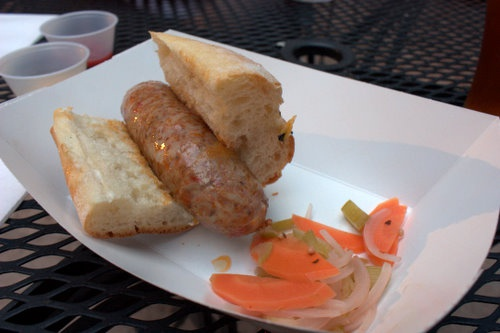Describe the objects in this image and their specific colors. I can see bowl in black, lightgray, darkgray, gray, and tan tones, hot dog in black, gray, brown, maroon, and tan tones, carrot in black, red, and brown tones, carrot in black, salmon, red, and brown tones, and cup in black and gray tones in this image. 